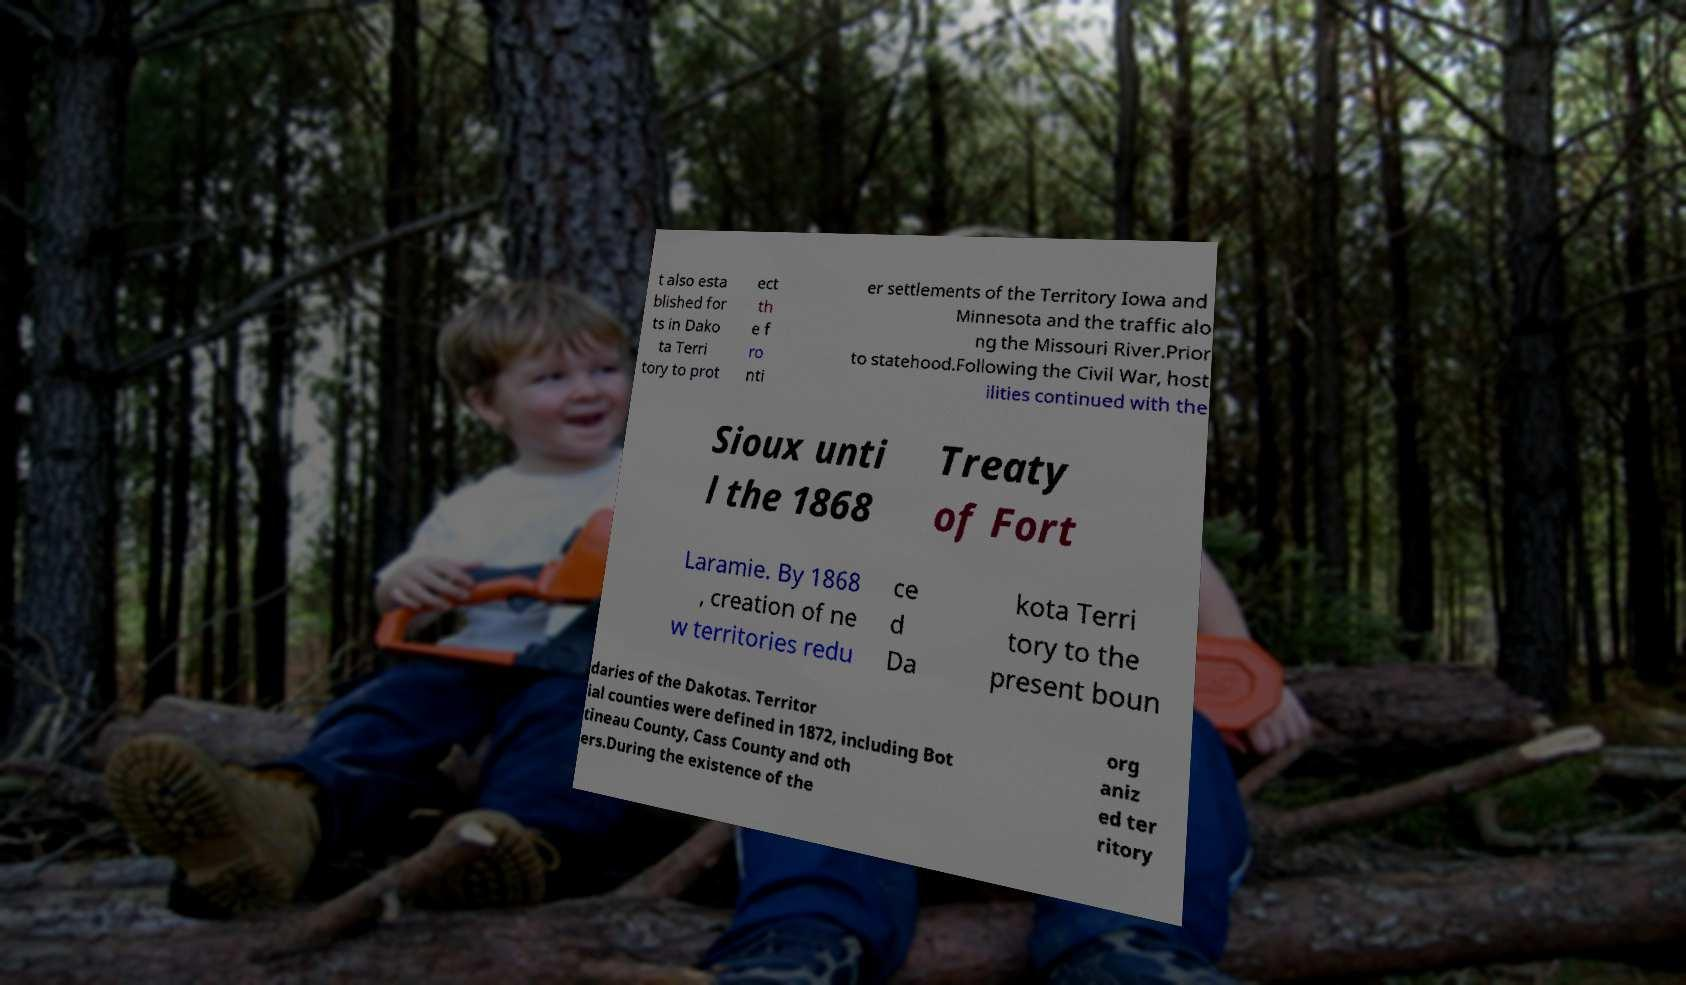Please read and relay the text visible in this image. What does it say? t also esta blished for ts in Dako ta Terri tory to prot ect th e f ro nti er settlements of the Territory Iowa and Minnesota and the traffic alo ng the Missouri River.Prior to statehood.Following the Civil War, host ilities continued with the Sioux unti l the 1868 Treaty of Fort Laramie. By 1868 , creation of ne w territories redu ce d Da kota Terri tory to the present boun daries of the Dakotas. Territor ial counties were defined in 1872, including Bot tineau County, Cass County and oth ers.During the existence of the org aniz ed ter ritory 